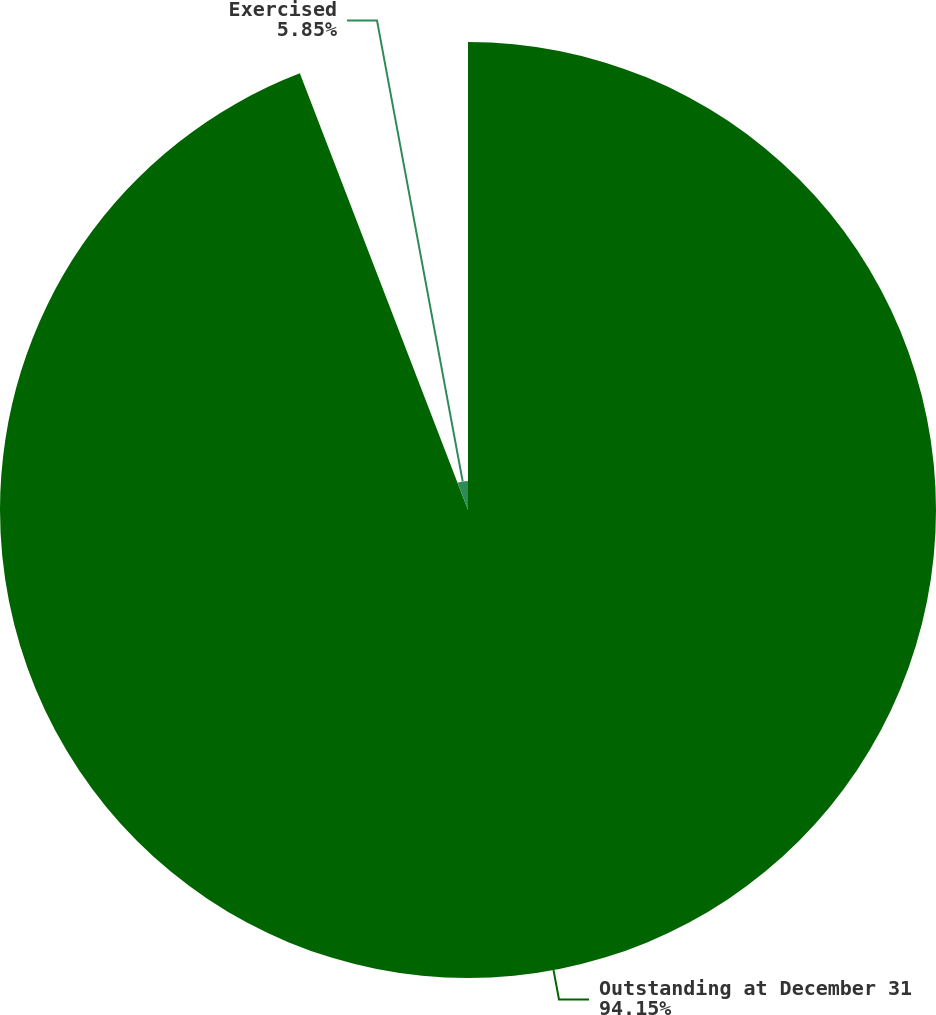Convert chart to OTSL. <chart><loc_0><loc_0><loc_500><loc_500><pie_chart><fcel>Outstanding at December 31<fcel>Exercised<nl><fcel>94.15%<fcel>5.85%<nl></chart> 